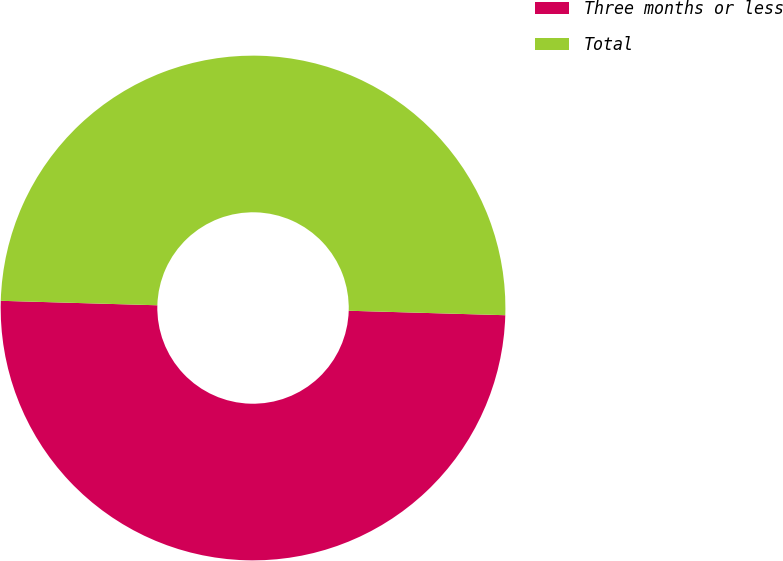<chart> <loc_0><loc_0><loc_500><loc_500><pie_chart><fcel>Three months or less<fcel>Total<nl><fcel>50.0%<fcel>50.0%<nl></chart> 